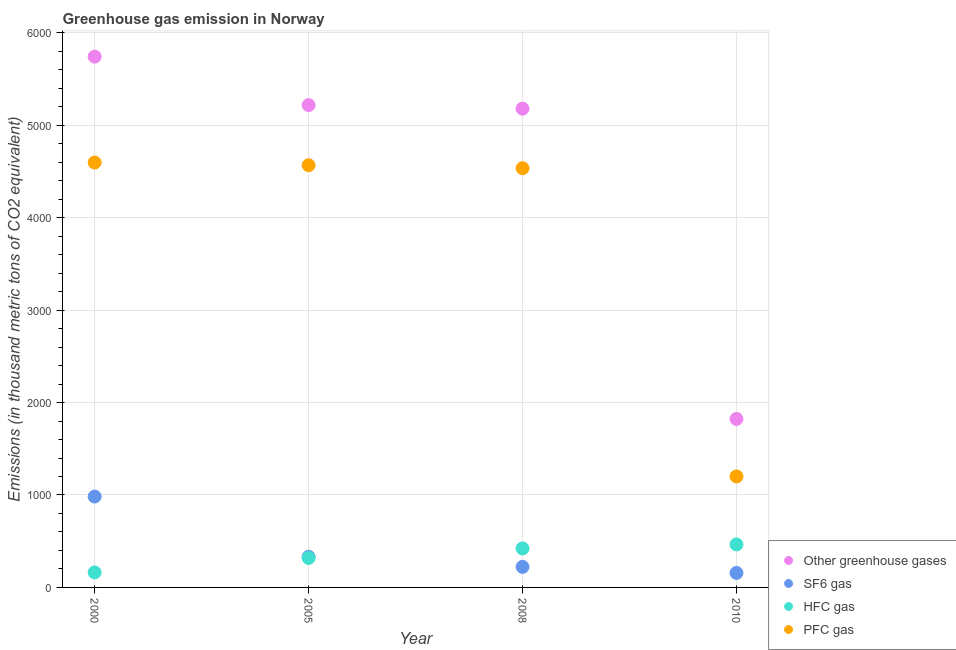How many different coloured dotlines are there?
Provide a succinct answer. 4. Is the number of dotlines equal to the number of legend labels?
Your response must be concise. Yes. What is the emission of sf6 gas in 2008?
Make the answer very short. 222.2. Across all years, what is the maximum emission of greenhouse gases?
Your answer should be compact. 5742.8. Across all years, what is the minimum emission of hfc gas?
Provide a short and direct response. 162.3. In which year was the emission of sf6 gas maximum?
Your response must be concise. 2000. In which year was the emission of hfc gas minimum?
Your response must be concise. 2000. What is the total emission of greenhouse gases in the graph?
Your answer should be very brief. 1.80e+04. What is the difference between the emission of sf6 gas in 2005 and that in 2008?
Ensure brevity in your answer.  109.2. What is the difference between the emission of pfc gas in 2010 and the emission of greenhouse gases in 2005?
Keep it short and to the point. -4017.5. What is the average emission of sf6 gas per year?
Your answer should be very brief. 423.45. In the year 2010, what is the difference between the emission of hfc gas and emission of sf6 gas?
Your answer should be compact. 308. What is the ratio of the emission of sf6 gas in 2000 to that in 2010?
Offer a terse response. 6.26. Is the difference between the emission of greenhouse gases in 2005 and 2008 greater than the difference between the emission of pfc gas in 2005 and 2008?
Offer a very short reply. Yes. What is the difference between the highest and the second highest emission of pfc gas?
Your response must be concise. 29.2. What is the difference between the highest and the lowest emission of greenhouse gases?
Provide a succinct answer. 3919.8. In how many years, is the emission of greenhouse gases greater than the average emission of greenhouse gases taken over all years?
Give a very brief answer. 3. Does the emission of pfc gas monotonically increase over the years?
Your response must be concise. No. Is the emission of pfc gas strictly greater than the emission of greenhouse gases over the years?
Give a very brief answer. No. How many dotlines are there?
Your answer should be compact. 4. How many years are there in the graph?
Give a very brief answer. 4. Are the values on the major ticks of Y-axis written in scientific E-notation?
Offer a terse response. No. Where does the legend appear in the graph?
Give a very brief answer. Bottom right. How many legend labels are there?
Provide a short and direct response. 4. How are the legend labels stacked?
Your response must be concise. Vertical. What is the title of the graph?
Ensure brevity in your answer.  Greenhouse gas emission in Norway. What is the label or title of the X-axis?
Provide a short and direct response. Year. What is the label or title of the Y-axis?
Provide a short and direct response. Emissions (in thousand metric tons of CO2 equivalent). What is the Emissions (in thousand metric tons of CO2 equivalent) in Other greenhouse gases in 2000?
Offer a terse response. 5742.8. What is the Emissions (in thousand metric tons of CO2 equivalent) of SF6 gas in 2000?
Your answer should be very brief. 983.2. What is the Emissions (in thousand metric tons of CO2 equivalent) in HFC gas in 2000?
Offer a very short reply. 162.3. What is the Emissions (in thousand metric tons of CO2 equivalent) in PFC gas in 2000?
Keep it short and to the point. 4597.3. What is the Emissions (in thousand metric tons of CO2 equivalent) in Other greenhouse gases in 2005?
Make the answer very short. 5218.5. What is the Emissions (in thousand metric tons of CO2 equivalent) of SF6 gas in 2005?
Your answer should be very brief. 331.4. What is the Emissions (in thousand metric tons of CO2 equivalent) of HFC gas in 2005?
Your response must be concise. 319. What is the Emissions (in thousand metric tons of CO2 equivalent) in PFC gas in 2005?
Make the answer very short. 4568.1. What is the Emissions (in thousand metric tons of CO2 equivalent) of Other greenhouse gases in 2008?
Make the answer very short. 5179.9. What is the Emissions (in thousand metric tons of CO2 equivalent) in SF6 gas in 2008?
Give a very brief answer. 222.2. What is the Emissions (in thousand metric tons of CO2 equivalent) of HFC gas in 2008?
Your answer should be compact. 422. What is the Emissions (in thousand metric tons of CO2 equivalent) of PFC gas in 2008?
Give a very brief answer. 4535.7. What is the Emissions (in thousand metric tons of CO2 equivalent) of Other greenhouse gases in 2010?
Provide a short and direct response. 1823. What is the Emissions (in thousand metric tons of CO2 equivalent) of SF6 gas in 2010?
Offer a very short reply. 157. What is the Emissions (in thousand metric tons of CO2 equivalent) in HFC gas in 2010?
Offer a terse response. 465. What is the Emissions (in thousand metric tons of CO2 equivalent) of PFC gas in 2010?
Your answer should be compact. 1201. Across all years, what is the maximum Emissions (in thousand metric tons of CO2 equivalent) in Other greenhouse gases?
Provide a succinct answer. 5742.8. Across all years, what is the maximum Emissions (in thousand metric tons of CO2 equivalent) of SF6 gas?
Make the answer very short. 983.2. Across all years, what is the maximum Emissions (in thousand metric tons of CO2 equivalent) in HFC gas?
Offer a very short reply. 465. Across all years, what is the maximum Emissions (in thousand metric tons of CO2 equivalent) of PFC gas?
Your answer should be compact. 4597.3. Across all years, what is the minimum Emissions (in thousand metric tons of CO2 equivalent) of Other greenhouse gases?
Give a very brief answer. 1823. Across all years, what is the minimum Emissions (in thousand metric tons of CO2 equivalent) of SF6 gas?
Offer a very short reply. 157. Across all years, what is the minimum Emissions (in thousand metric tons of CO2 equivalent) of HFC gas?
Make the answer very short. 162.3. Across all years, what is the minimum Emissions (in thousand metric tons of CO2 equivalent) in PFC gas?
Provide a succinct answer. 1201. What is the total Emissions (in thousand metric tons of CO2 equivalent) of Other greenhouse gases in the graph?
Ensure brevity in your answer.  1.80e+04. What is the total Emissions (in thousand metric tons of CO2 equivalent) of SF6 gas in the graph?
Your response must be concise. 1693.8. What is the total Emissions (in thousand metric tons of CO2 equivalent) in HFC gas in the graph?
Keep it short and to the point. 1368.3. What is the total Emissions (in thousand metric tons of CO2 equivalent) in PFC gas in the graph?
Your answer should be compact. 1.49e+04. What is the difference between the Emissions (in thousand metric tons of CO2 equivalent) in Other greenhouse gases in 2000 and that in 2005?
Offer a terse response. 524.3. What is the difference between the Emissions (in thousand metric tons of CO2 equivalent) of SF6 gas in 2000 and that in 2005?
Your answer should be compact. 651.8. What is the difference between the Emissions (in thousand metric tons of CO2 equivalent) of HFC gas in 2000 and that in 2005?
Ensure brevity in your answer.  -156.7. What is the difference between the Emissions (in thousand metric tons of CO2 equivalent) of PFC gas in 2000 and that in 2005?
Your answer should be very brief. 29.2. What is the difference between the Emissions (in thousand metric tons of CO2 equivalent) of Other greenhouse gases in 2000 and that in 2008?
Make the answer very short. 562.9. What is the difference between the Emissions (in thousand metric tons of CO2 equivalent) of SF6 gas in 2000 and that in 2008?
Ensure brevity in your answer.  761. What is the difference between the Emissions (in thousand metric tons of CO2 equivalent) in HFC gas in 2000 and that in 2008?
Your answer should be compact. -259.7. What is the difference between the Emissions (in thousand metric tons of CO2 equivalent) of PFC gas in 2000 and that in 2008?
Give a very brief answer. 61.6. What is the difference between the Emissions (in thousand metric tons of CO2 equivalent) of Other greenhouse gases in 2000 and that in 2010?
Offer a very short reply. 3919.8. What is the difference between the Emissions (in thousand metric tons of CO2 equivalent) of SF6 gas in 2000 and that in 2010?
Offer a terse response. 826.2. What is the difference between the Emissions (in thousand metric tons of CO2 equivalent) of HFC gas in 2000 and that in 2010?
Your response must be concise. -302.7. What is the difference between the Emissions (in thousand metric tons of CO2 equivalent) of PFC gas in 2000 and that in 2010?
Ensure brevity in your answer.  3396.3. What is the difference between the Emissions (in thousand metric tons of CO2 equivalent) of Other greenhouse gases in 2005 and that in 2008?
Offer a very short reply. 38.6. What is the difference between the Emissions (in thousand metric tons of CO2 equivalent) of SF6 gas in 2005 and that in 2008?
Offer a terse response. 109.2. What is the difference between the Emissions (in thousand metric tons of CO2 equivalent) in HFC gas in 2005 and that in 2008?
Your response must be concise. -103. What is the difference between the Emissions (in thousand metric tons of CO2 equivalent) of PFC gas in 2005 and that in 2008?
Ensure brevity in your answer.  32.4. What is the difference between the Emissions (in thousand metric tons of CO2 equivalent) of Other greenhouse gases in 2005 and that in 2010?
Keep it short and to the point. 3395.5. What is the difference between the Emissions (in thousand metric tons of CO2 equivalent) in SF6 gas in 2005 and that in 2010?
Offer a terse response. 174.4. What is the difference between the Emissions (in thousand metric tons of CO2 equivalent) in HFC gas in 2005 and that in 2010?
Offer a very short reply. -146. What is the difference between the Emissions (in thousand metric tons of CO2 equivalent) of PFC gas in 2005 and that in 2010?
Your response must be concise. 3367.1. What is the difference between the Emissions (in thousand metric tons of CO2 equivalent) of Other greenhouse gases in 2008 and that in 2010?
Your response must be concise. 3356.9. What is the difference between the Emissions (in thousand metric tons of CO2 equivalent) in SF6 gas in 2008 and that in 2010?
Your response must be concise. 65.2. What is the difference between the Emissions (in thousand metric tons of CO2 equivalent) of HFC gas in 2008 and that in 2010?
Your answer should be very brief. -43. What is the difference between the Emissions (in thousand metric tons of CO2 equivalent) of PFC gas in 2008 and that in 2010?
Provide a succinct answer. 3334.7. What is the difference between the Emissions (in thousand metric tons of CO2 equivalent) of Other greenhouse gases in 2000 and the Emissions (in thousand metric tons of CO2 equivalent) of SF6 gas in 2005?
Ensure brevity in your answer.  5411.4. What is the difference between the Emissions (in thousand metric tons of CO2 equivalent) in Other greenhouse gases in 2000 and the Emissions (in thousand metric tons of CO2 equivalent) in HFC gas in 2005?
Give a very brief answer. 5423.8. What is the difference between the Emissions (in thousand metric tons of CO2 equivalent) of Other greenhouse gases in 2000 and the Emissions (in thousand metric tons of CO2 equivalent) of PFC gas in 2005?
Offer a terse response. 1174.7. What is the difference between the Emissions (in thousand metric tons of CO2 equivalent) in SF6 gas in 2000 and the Emissions (in thousand metric tons of CO2 equivalent) in HFC gas in 2005?
Your response must be concise. 664.2. What is the difference between the Emissions (in thousand metric tons of CO2 equivalent) of SF6 gas in 2000 and the Emissions (in thousand metric tons of CO2 equivalent) of PFC gas in 2005?
Provide a succinct answer. -3584.9. What is the difference between the Emissions (in thousand metric tons of CO2 equivalent) of HFC gas in 2000 and the Emissions (in thousand metric tons of CO2 equivalent) of PFC gas in 2005?
Your answer should be compact. -4405.8. What is the difference between the Emissions (in thousand metric tons of CO2 equivalent) of Other greenhouse gases in 2000 and the Emissions (in thousand metric tons of CO2 equivalent) of SF6 gas in 2008?
Provide a succinct answer. 5520.6. What is the difference between the Emissions (in thousand metric tons of CO2 equivalent) of Other greenhouse gases in 2000 and the Emissions (in thousand metric tons of CO2 equivalent) of HFC gas in 2008?
Offer a terse response. 5320.8. What is the difference between the Emissions (in thousand metric tons of CO2 equivalent) in Other greenhouse gases in 2000 and the Emissions (in thousand metric tons of CO2 equivalent) in PFC gas in 2008?
Provide a succinct answer. 1207.1. What is the difference between the Emissions (in thousand metric tons of CO2 equivalent) in SF6 gas in 2000 and the Emissions (in thousand metric tons of CO2 equivalent) in HFC gas in 2008?
Your answer should be compact. 561.2. What is the difference between the Emissions (in thousand metric tons of CO2 equivalent) in SF6 gas in 2000 and the Emissions (in thousand metric tons of CO2 equivalent) in PFC gas in 2008?
Your response must be concise. -3552.5. What is the difference between the Emissions (in thousand metric tons of CO2 equivalent) in HFC gas in 2000 and the Emissions (in thousand metric tons of CO2 equivalent) in PFC gas in 2008?
Your response must be concise. -4373.4. What is the difference between the Emissions (in thousand metric tons of CO2 equivalent) of Other greenhouse gases in 2000 and the Emissions (in thousand metric tons of CO2 equivalent) of SF6 gas in 2010?
Provide a short and direct response. 5585.8. What is the difference between the Emissions (in thousand metric tons of CO2 equivalent) of Other greenhouse gases in 2000 and the Emissions (in thousand metric tons of CO2 equivalent) of HFC gas in 2010?
Provide a succinct answer. 5277.8. What is the difference between the Emissions (in thousand metric tons of CO2 equivalent) in Other greenhouse gases in 2000 and the Emissions (in thousand metric tons of CO2 equivalent) in PFC gas in 2010?
Offer a very short reply. 4541.8. What is the difference between the Emissions (in thousand metric tons of CO2 equivalent) of SF6 gas in 2000 and the Emissions (in thousand metric tons of CO2 equivalent) of HFC gas in 2010?
Your response must be concise. 518.2. What is the difference between the Emissions (in thousand metric tons of CO2 equivalent) in SF6 gas in 2000 and the Emissions (in thousand metric tons of CO2 equivalent) in PFC gas in 2010?
Offer a terse response. -217.8. What is the difference between the Emissions (in thousand metric tons of CO2 equivalent) of HFC gas in 2000 and the Emissions (in thousand metric tons of CO2 equivalent) of PFC gas in 2010?
Your answer should be very brief. -1038.7. What is the difference between the Emissions (in thousand metric tons of CO2 equivalent) of Other greenhouse gases in 2005 and the Emissions (in thousand metric tons of CO2 equivalent) of SF6 gas in 2008?
Offer a terse response. 4996.3. What is the difference between the Emissions (in thousand metric tons of CO2 equivalent) of Other greenhouse gases in 2005 and the Emissions (in thousand metric tons of CO2 equivalent) of HFC gas in 2008?
Keep it short and to the point. 4796.5. What is the difference between the Emissions (in thousand metric tons of CO2 equivalent) in Other greenhouse gases in 2005 and the Emissions (in thousand metric tons of CO2 equivalent) in PFC gas in 2008?
Ensure brevity in your answer.  682.8. What is the difference between the Emissions (in thousand metric tons of CO2 equivalent) of SF6 gas in 2005 and the Emissions (in thousand metric tons of CO2 equivalent) of HFC gas in 2008?
Offer a very short reply. -90.6. What is the difference between the Emissions (in thousand metric tons of CO2 equivalent) in SF6 gas in 2005 and the Emissions (in thousand metric tons of CO2 equivalent) in PFC gas in 2008?
Your answer should be compact. -4204.3. What is the difference between the Emissions (in thousand metric tons of CO2 equivalent) of HFC gas in 2005 and the Emissions (in thousand metric tons of CO2 equivalent) of PFC gas in 2008?
Your answer should be compact. -4216.7. What is the difference between the Emissions (in thousand metric tons of CO2 equivalent) of Other greenhouse gases in 2005 and the Emissions (in thousand metric tons of CO2 equivalent) of SF6 gas in 2010?
Your answer should be compact. 5061.5. What is the difference between the Emissions (in thousand metric tons of CO2 equivalent) of Other greenhouse gases in 2005 and the Emissions (in thousand metric tons of CO2 equivalent) of HFC gas in 2010?
Offer a very short reply. 4753.5. What is the difference between the Emissions (in thousand metric tons of CO2 equivalent) of Other greenhouse gases in 2005 and the Emissions (in thousand metric tons of CO2 equivalent) of PFC gas in 2010?
Provide a succinct answer. 4017.5. What is the difference between the Emissions (in thousand metric tons of CO2 equivalent) in SF6 gas in 2005 and the Emissions (in thousand metric tons of CO2 equivalent) in HFC gas in 2010?
Make the answer very short. -133.6. What is the difference between the Emissions (in thousand metric tons of CO2 equivalent) of SF6 gas in 2005 and the Emissions (in thousand metric tons of CO2 equivalent) of PFC gas in 2010?
Offer a terse response. -869.6. What is the difference between the Emissions (in thousand metric tons of CO2 equivalent) in HFC gas in 2005 and the Emissions (in thousand metric tons of CO2 equivalent) in PFC gas in 2010?
Your response must be concise. -882. What is the difference between the Emissions (in thousand metric tons of CO2 equivalent) of Other greenhouse gases in 2008 and the Emissions (in thousand metric tons of CO2 equivalent) of SF6 gas in 2010?
Your response must be concise. 5022.9. What is the difference between the Emissions (in thousand metric tons of CO2 equivalent) of Other greenhouse gases in 2008 and the Emissions (in thousand metric tons of CO2 equivalent) of HFC gas in 2010?
Offer a very short reply. 4714.9. What is the difference between the Emissions (in thousand metric tons of CO2 equivalent) of Other greenhouse gases in 2008 and the Emissions (in thousand metric tons of CO2 equivalent) of PFC gas in 2010?
Your answer should be very brief. 3978.9. What is the difference between the Emissions (in thousand metric tons of CO2 equivalent) of SF6 gas in 2008 and the Emissions (in thousand metric tons of CO2 equivalent) of HFC gas in 2010?
Provide a succinct answer. -242.8. What is the difference between the Emissions (in thousand metric tons of CO2 equivalent) of SF6 gas in 2008 and the Emissions (in thousand metric tons of CO2 equivalent) of PFC gas in 2010?
Make the answer very short. -978.8. What is the difference between the Emissions (in thousand metric tons of CO2 equivalent) in HFC gas in 2008 and the Emissions (in thousand metric tons of CO2 equivalent) in PFC gas in 2010?
Make the answer very short. -779. What is the average Emissions (in thousand metric tons of CO2 equivalent) of Other greenhouse gases per year?
Your answer should be compact. 4491.05. What is the average Emissions (in thousand metric tons of CO2 equivalent) in SF6 gas per year?
Offer a terse response. 423.45. What is the average Emissions (in thousand metric tons of CO2 equivalent) of HFC gas per year?
Give a very brief answer. 342.07. What is the average Emissions (in thousand metric tons of CO2 equivalent) of PFC gas per year?
Ensure brevity in your answer.  3725.53. In the year 2000, what is the difference between the Emissions (in thousand metric tons of CO2 equivalent) of Other greenhouse gases and Emissions (in thousand metric tons of CO2 equivalent) of SF6 gas?
Your response must be concise. 4759.6. In the year 2000, what is the difference between the Emissions (in thousand metric tons of CO2 equivalent) in Other greenhouse gases and Emissions (in thousand metric tons of CO2 equivalent) in HFC gas?
Provide a succinct answer. 5580.5. In the year 2000, what is the difference between the Emissions (in thousand metric tons of CO2 equivalent) of Other greenhouse gases and Emissions (in thousand metric tons of CO2 equivalent) of PFC gas?
Keep it short and to the point. 1145.5. In the year 2000, what is the difference between the Emissions (in thousand metric tons of CO2 equivalent) of SF6 gas and Emissions (in thousand metric tons of CO2 equivalent) of HFC gas?
Your answer should be compact. 820.9. In the year 2000, what is the difference between the Emissions (in thousand metric tons of CO2 equivalent) of SF6 gas and Emissions (in thousand metric tons of CO2 equivalent) of PFC gas?
Offer a very short reply. -3614.1. In the year 2000, what is the difference between the Emissions (in thousand metric tons of CO2 equivalent) in HFC gas and Emissions (in thousand metric tons of CO2 equivalent) in PFC gas?
Give a very brief answer. -4435. In the year 2005, what is the difference between the Emissions (in thousand metric tons of CO2 equivalent) in Other greenhouse gases and Emissions (in thousand metric tons of CO2 equivalent) in SF6 gas?
Your answer should be compact. 4887.1. In the year 2005, what is the difference between the Emissions (in thousand metric tons of CO2 equivalent) in Other greenhouse gases and Emissions (in thousand metric tons of CO2 equivalent) in HFC gas?
Provide a succinct answer. 4899.5. In the year 2005, what is the difference between the Emissions (in thousand metric tons of CO2 equivalent) in Other greenhouse gases and Emissions (in thousand metric tons of CO2 equivalent) in PFC gas?
Keep it short and to the point. 650.4. In the year 2005, what is the difference between the Emissions (in thousand metric tons of CO2 equivalent) of SF6 gas and Emissions (in thousand metric tons of CO2 equivalent) of HFC gas?
Provide a short and direct response. 12.4. In the year 2005, what is the difference between the Emissions (in thousand metric tons of CO2 equivalent) of SF6 gas and Emissions (in thousand metric tons of CO2 equivalent) of PFC gas?
Your answer should be compact. -4236.7. In the year 2005, what is the difference between the Emissions (in thousand metric tons of CO2 equivalent) of HFC gas and Emissions (in thousand metric tons of CO2 equivalent) of PFC gas?
Your answer should be very brief. -4249.1. In the year 2008, what is the difference between the Emissions (in thousand metric tons of CO2 equivalent) in Other greenhouse gases and Emissions (in thousand metric tons of CO2 equivalent) in SF6 gas?
Your answer should be compact. 4957.7. In the year 2008, what is the difference between the Emissions (in thousand metric tons of CO2 equivalent) of Other greenhouse gases and Emissions (in thousand metric tons of CO2 equivalent) of HFC gas?
Provide a short and direct response. 4757.9. In the year 2008, what is the difference between the Emissions (in thousand metric tons of CO2 equivalent) of Other greenhouse gases and Emissions (in thousand metric tons of CO2 equivalent) of PFC gas?
Provide a succinct answer. 644.2. In the year 2008, what is the difference between the Emissions (in thousand metric tons of CO2 equivalent) of SF6 gas and Emissions (in thousand metric tons of CO2 equivalent) of HFC gas?
Keep it short and to the point. -199.8. In the year 2008, what is the difference between the Emissions (in thousand metric tons of CO2 equivalent) of SF6 gas and Emissions (in thousand metric tons of CO2 equivalent) of PFC gas?
Provide a succinct answer. -4313.5. In the year 2008, what is the difference between the Emissions (in thousand metric tons of CO2 equivalent) in HFC gas and Emissions (in thousand metric tons of CO2 equivalent) in PFC gas?
Offer a very short reply. -4113.7. In the year 2010, what is the difference between the Emissions (in thousand metric tons of CO2 equivalent) in Other greenhouse gases and Emissions (in thousand metric tons of CO2 equivalent) in SF6 gas?
Offer a very short reply. 1666. In the year 2010, what is the difference between the Emissions (in thousand metric tons of CO2 equivalent) of Other greenhouse gases and Emissions (in thousand metric tons of CO2 equivalent) of HFC gas?
Provide a succinct answer. 1358. In the year 2010, what is the difference between the Emissions (in thousand metric tons of CO2 equivalent) in Other greenhouse gases and Emissions (in thousand metric tons of CO2 equivalent) in PFC gas?
Ensure brevity in your answer.  622. In the year 2010, what is the difference between the Emissions (in thousand metric tons of CO2 equivalent) in SF6 gas and Emissions (in thousand metric tons of CO2 equivalent) in HFC gas?
Provide a short and direct response. -308. In the year 2010, what is the difference between the Emissions (in thousand metric tons of CO2 equivalent) in SF6 gas and Emissions (in thousand metric tons of CO2 equivalent) in PFC gas?
Provide a short and direct response. -1044. In the year 2010, what is the difference between the Emissions (in thousand metric tons of CO2 equivalent) of HFC gas and Emissions (in thousand metric tons of CO2 equivalent) of PFC gas?
Give a very brief answer. -736. What is the ratio of the Emissions (in thousand metric tons of CO2 equivalent) in Other greenhouse gases in 2000 to that in 2005?
Give a very brief answer. 1.1. What is the ratio of the Emissions (in thousand metric tons of CO2 equivalent) in SF6 gas in 2000 to that in 2005?
Provide a succinct answer. 2.97. What is the ratio of the Emissions (in thousand metric tons of CO2 equivalent) in HFC gas in 2000 to that in 2005?
Your answer should be compact. 0.51. What is the ratio of the Emissions (in thousand metric tons of CO2 equivalent) of PFC gas in 2000 to that in 2005?
Your answer should be very brief. 1.01. What is the ratio of the Emissions (in thousand metric tons of CO2 equivalent) in Other greenhouse gases in 2000 to that in 2008?
Ensure brevity in your answer.  1.11. What is the ratio of the Emissions (in thousand metric tons of CO2 equivalent) of SF6 gas in 2000 to that in 2008?
Offer a terse response. 4.42. What is the ratio of the Emissions (in thousand metric tons of CO2 equivalent) in HFC gas in 2000 to that in 2008?
Provide a short and direct response. 0.38. What is the ratio of the Emissions (in thousand metric tons of CO2 equivalent) of PFC gas in 2000 to that in 2008?
Offer a terse response. 1.01. What is the ratio of the Emissions (in thousand metric tons of CO2 equivalent) in Other greenhouse gases in 2000 to that in 2010?
Offer a very short reply. 3.15. What is the ratio of the Emissions (in thousand metric tons of CO2 equivalent) of SF6 gas in 2000 to that in 2010?
Give a very brief answer. 6.26. What is the ratio of the Emissions (in thousand metric tons of CO2 equivalent) of HFC gas in 2000 to that in 2010?
Give a very brief answer. 0.35. What is the ratio of the Emissions (in thousand metric tons of CO2 equivalent) of PFC gas in 2000 to that in 2010?
Your answer should be compact. 3.83. What is the ratio of the Emissions (in thousand metric tons of CO2 equivalent) of Other greenhouse gases in 2005 to that in 2008?
Give a very brief answer. 1.01. What is the ratio of the Emissions (in thousand metric tons of CO2 equivalent) of SF6 gas in 2005 to that in 2008?
Provide a succinct answer. 1.49. What is the ratio of the Emissions (in thousand metric tons of CO2 equivalent) of HFC gas in 2005 to that in 2008?
Offer a very short reply. 0.76. What is the ratio of the Emissions (in thousand metric tons of CO2 equivalent) of PFC gas in 2005 to that in 2008?
Ensure brevity in your answer.  1.01. What is the ratio of the Emissions (in thousand metric tons of CO2 equivalent) in Other greenhouse gases in 2005 to that in 2010?
Offer a terse response. 2.86. What is the ratio of the Emissions (in thousand metric tons of CO2 equivalent) in SF6 gas in 2005 to that in 2010?
Provide a short and direct response. 2.11. What is the ratio of the Emissions (in thousand metric tons of CO2 equivalent) in HFC gas in 2005 to that in 2010?
Offer a very short reply. 0.69. What is the ratio of the Emissions (in thousand metric tons of CO2 equivalent) in PFC gas in 2005 to that in 2010?
Ensure brevity in your answer.  3.8. What is the ratio of the Emissions (in thousand metric tons of CO2 equivalent) in Other greenhouse gases in 2008 to that in 2010?
Provide a short and direct response. 2.84. What is the ratio of the Emissions (in thousand metric tons of CO2 equivalent) of SF6 gas in 2008 to that in 2010?
Your answer should be compact. 1.42. What is the ratio of the Emissions (in thousand metric tons of CO2 equivalent) of HFC gas in 2008 to that in 2010?
Provide a short and direct response. 0.91. What is the ratio of the Emissions (in thousand metric tons of CO2 equivalent) of PFC gas in 2008 to that in 2010?
Provide a succinct answer. 3.78. What is the difference between the highest and the second highest Emissions (in thousand metric tons of CO2 equivalent) of Other greenhouse gases?
Your response must be concise. 524.3. What is the difference between the highest and the second highest Emissions (in thousand metric tons of CO2 equivalent) of SF6 gas?
Your answer should be compact. 651.8. What is the difference between the highest and the second highest Emissions (in thousand metric tons of CO2 equivalent) in PFC gas?
Provide a short and direct response. 29.2. What is the difference between the highest and the lowest Emissions (in thousand metric tons of CO2 equivalent) of Other greenhouse gases?
Provide a short and direct response. 3919.8. What is the difference between the highest and the lowest Emissions (in thousand metric tons of CO2 equivalent) in SF6 gas?
Your response must be concise. 826.2. What is the difference between the highest and the lowest Emissions (in thousand metric tons of CO2 equivalent) of HFC gas?
Give a very brief answer. 302.7. What is the difference between the highest and the lowest Emissions (in thousand metric tons of CO2 equivalent) of PFC gas?
Provide a succinct answer. 3396.3. 